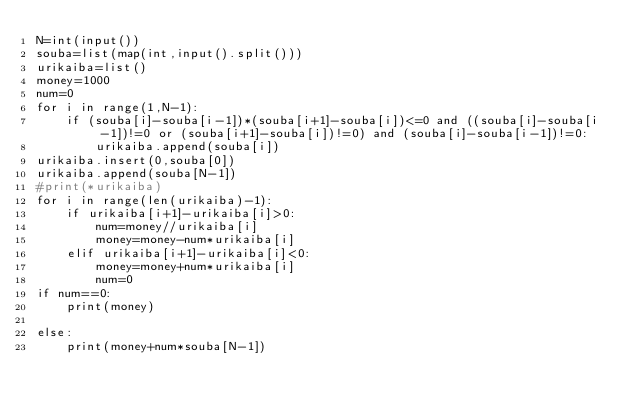<code> <loc_0><loc_0><loc_500><loc_500><_Python_>N=int(input())
souba=list(map(int,input().split()))
urikaiba=list()
money=1000
num=0
for i in range(1,N-1):
    if (souba[i]-souba[i-1])*(souba[i+1]-souba[i])<=0 and ((souba[i]-souba[i-1])!=0 or (souba[i+1]-souba[i])!=0) and (souba[i]-souba[i-1])!=0:
        urikaiba.append(souba[i])
urikaiba.insert(0,souba[0])
urikaiba.append(souba[N-1])
#print(*urikaiba)
for i in range(len(urikaiba)-1):
    if urikaiba[i+1]-urikaiba[i]>0:
        num=money//urikaiba[i]
        money=money-num*urikaiba[i]
    elif urikaiba[i+1]-urikaiba[i]<0:
        money=money+num*urikaiba[i]
        num=0
if num==0:
    print(money)

else:
    print(money+num*souba[N-1])



</code> 